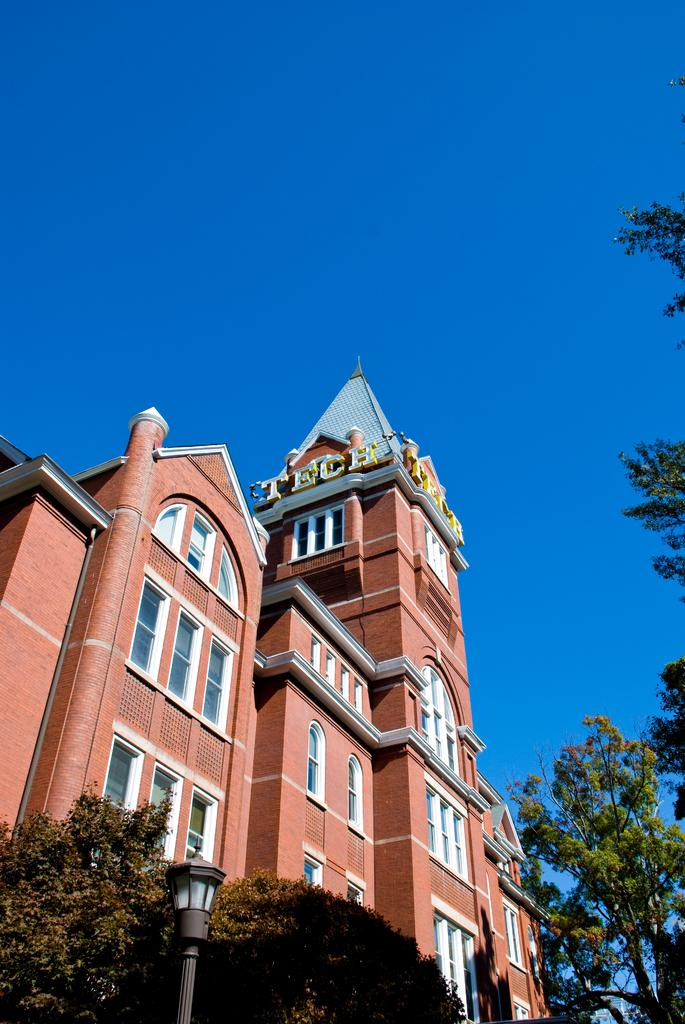What type of structure is the main subject in the image? There is a tall building in the image. What can be seen around the building? There are trees around the building. Can you describe the lighting source on the left side of the image? There is a pole light on the left side of the image, in front of the trees. How many legs does the building have in the image? Buildings do not have legs; they are stationary structures. The question is not applicable to the image. 